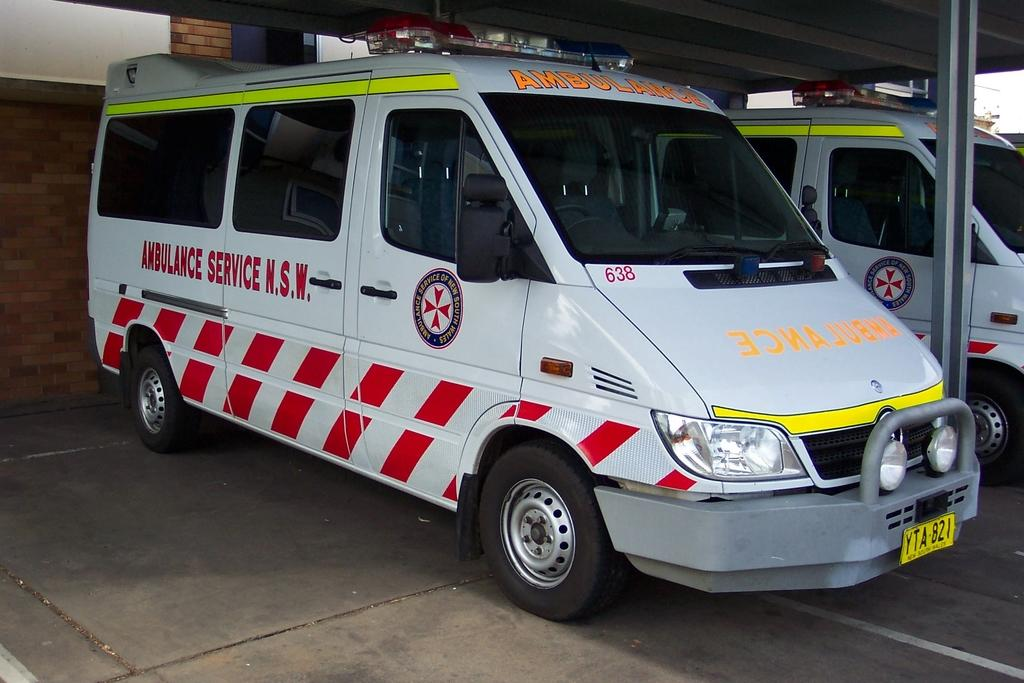<image>
Write a terse but informative summary of the picture. a van that is functioning as an ambulance, it is mostly white 